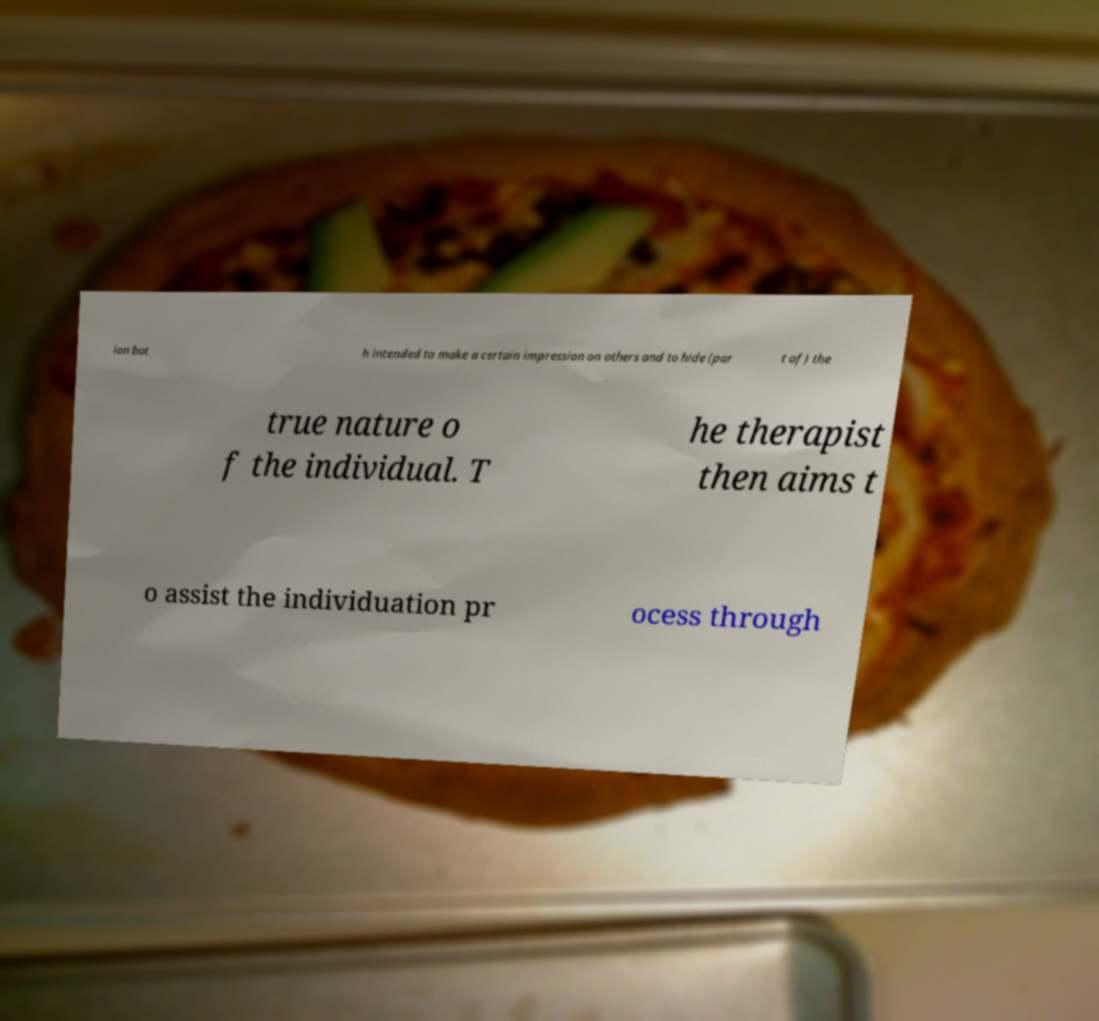Could you extract and type out the text from this image? ion bot h intended to make a certain impression on others and to hide (par t of) the true nature o f the individual. T he therapist then aims t o assist the individuation pr ocess through 